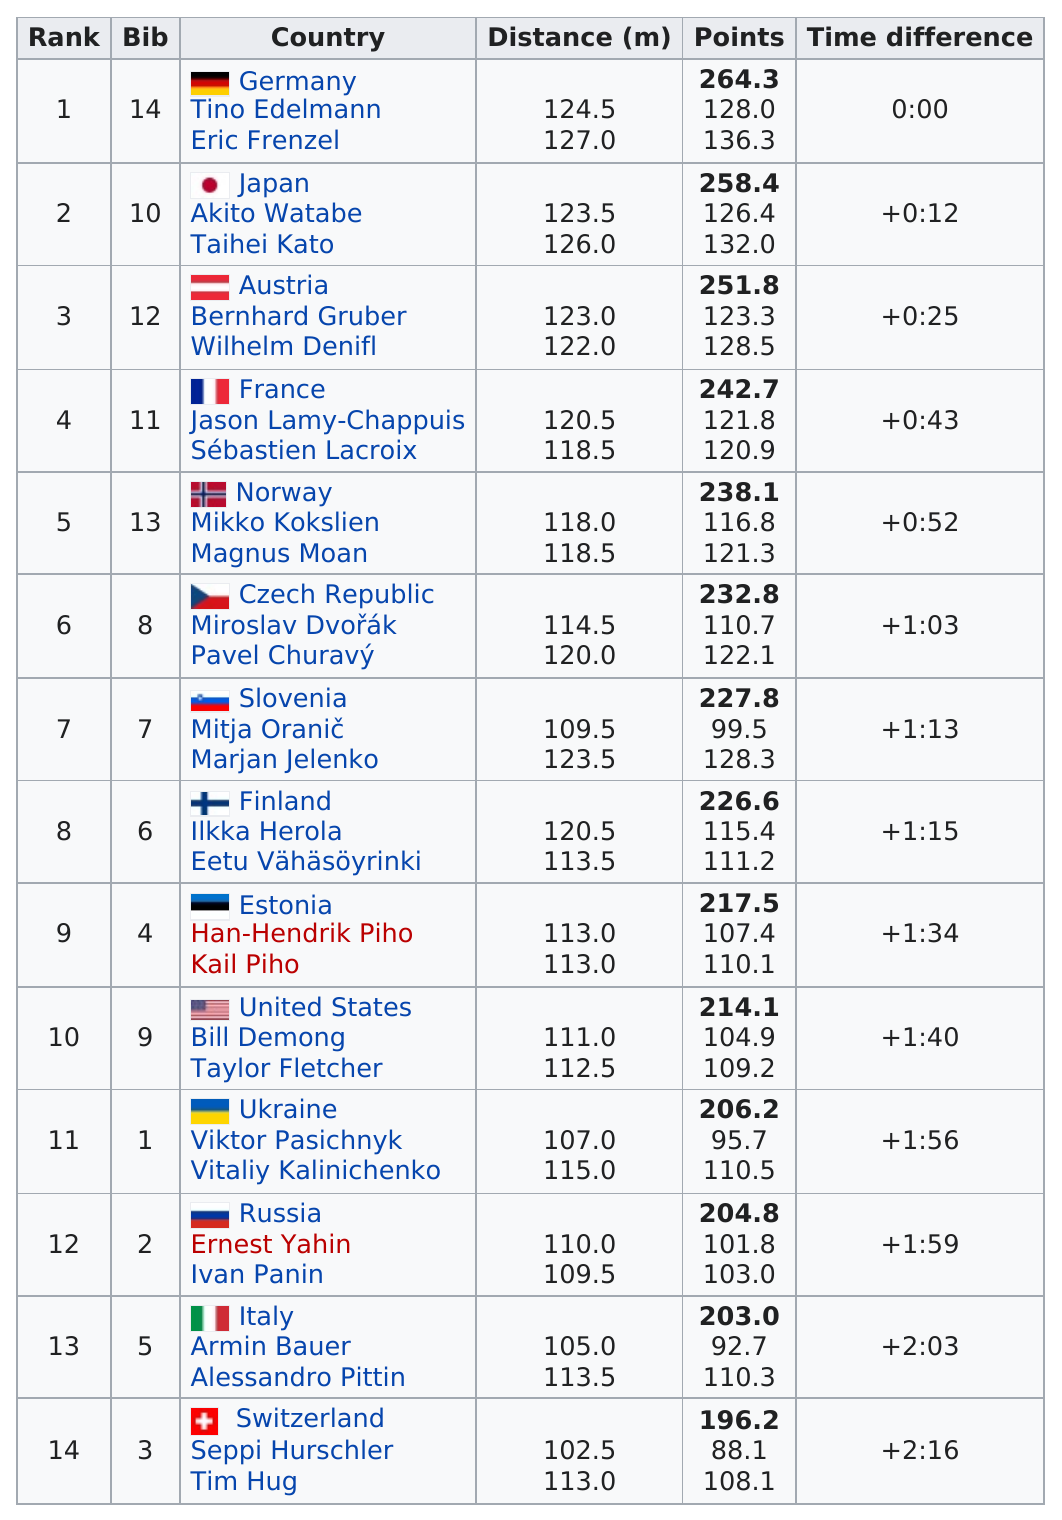Indicate a few pertinent items in this graphic. The country with the next farthest distance from Norway is the Czech Republic. Mikko Koskinen and Magnus Moan combined for a total distance of 236.5 in this competition. Six countries have fewer than 220 points. Germany has the top athlete in terms of distance. The time difference between France and the United States was 57 seconds. 